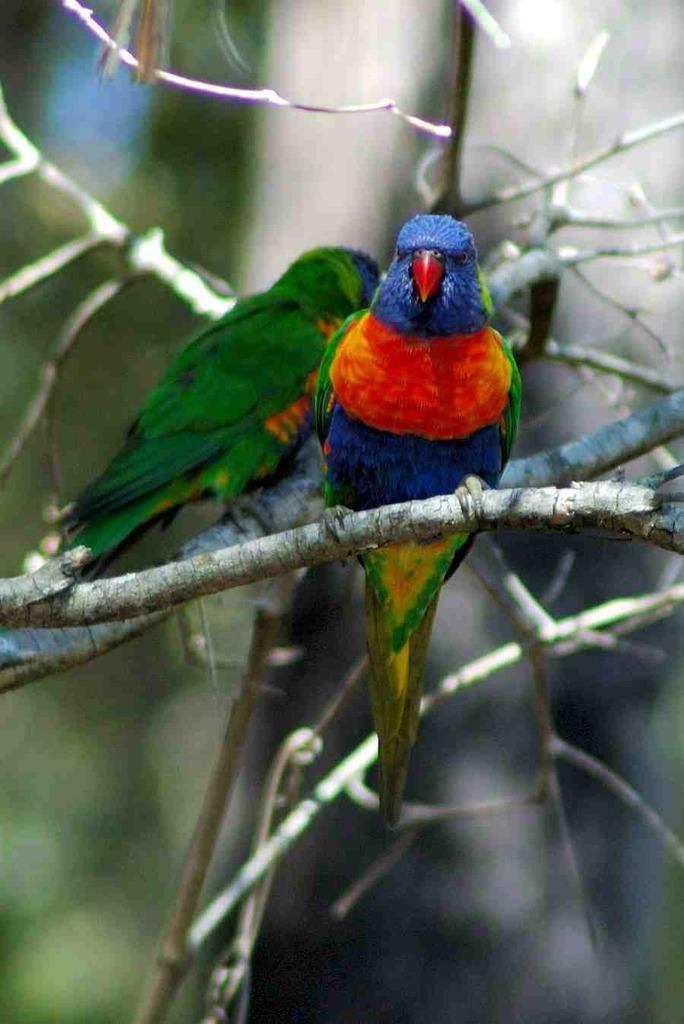How many parrots are in the image? There are two parrots in the image. Where might the parrots be located in the image? The parrots may be on the stem of a tree. Can you describe the background of the image? The background of the image is blurry. Who made the request for the parrots to drop the keys in the image? There is no mention of keys or a request in the image, so it cannot be determined who made such a request. 